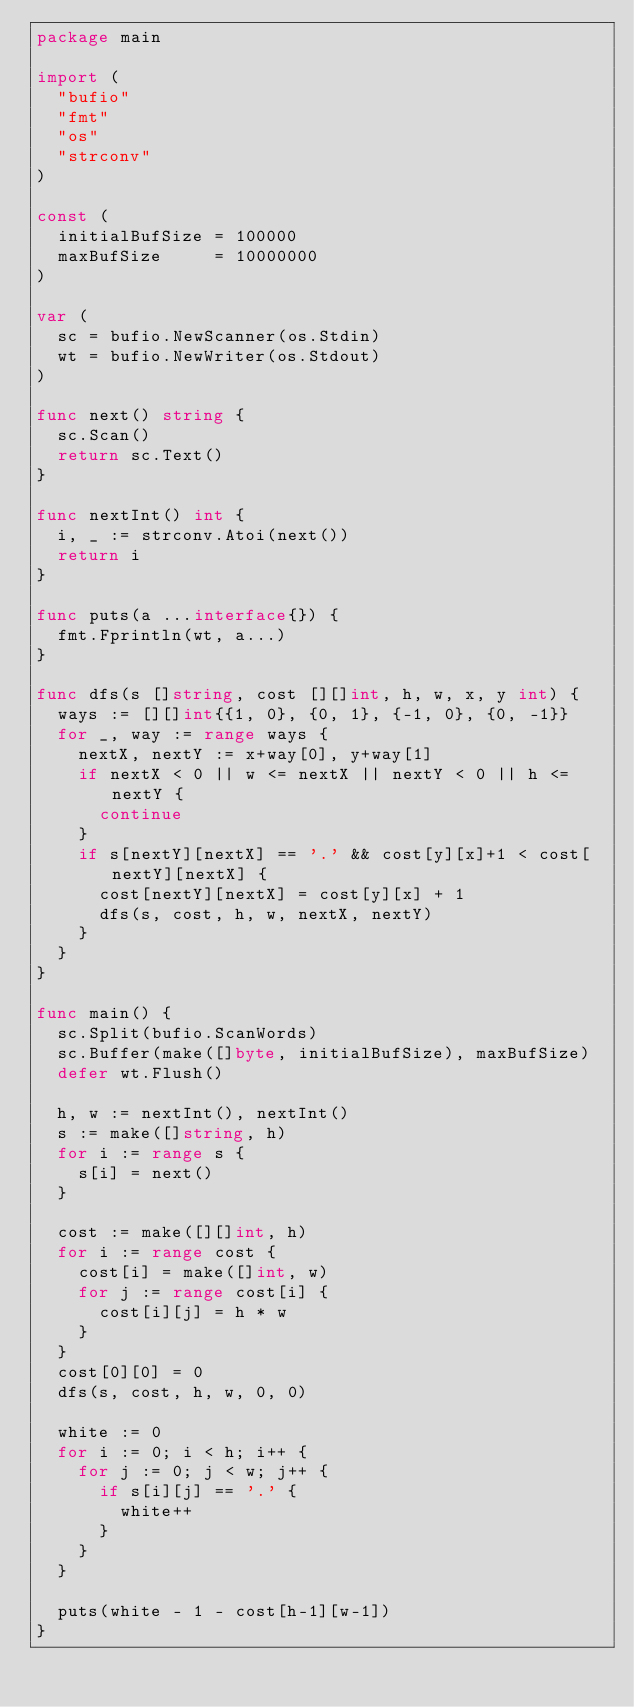<code> <loc_0><loc_0><loc_500><loc_500><_Go_>package main

import (
	"bufio"
	"fmt"
	"os"
	"strconv"
)

const (
	initialBufSize = 100000
	maxBufSize     = 10000000
)

var (
	sc = bufio.NewScanner(os.Stdin)
	wt = bufio.NewWriter(os.Stdout)
)

func next() string {
	sc.Scan()
	return sc.Text()
}

func nextInt() int {
	i, _ := strconv.Atoi(next())
	return i
}

func puts(a ...interface{}) {
	fmt.Fprintln(wt, a...)
}

func dfs(s []string, cost [][]int, h, w, x, y int) {
	ways := [][]int{{1, 0}, {0, 1}, {-1, 0}, {0, -1}}
	for _, way := range ways {
		nextX, nextY := x+way[0], y+way[1]
		if nextX < 0 || w <= nextX || nextY < 0 || h <= nextY {
			continue
		}
		if s[nextY][nextX] == '.' && cost[y][x]+1 < cost[nextY][nextX] {
			cost[nextY][nextX] = cost[y][x] + 1
			dfs(s, cost, h, w, nextX, nextY)
		}
	}
}

func main() {
	sc.Split(bufio.ScanWords)
	sc.Buffer(make([]byte, initialBufSize), maxBufSize)
	defer wt.Flush()

	h, w := nextInt(), nextInt()
	s := make([]string, h)
	for i := range s {
		s[i] = next()
	}

	cost := make([][]int, h)
	for i := range cost {
		cost[i] = make([]int, w)
		for j := range cost[i] {
			cost[i][j] = h * w
		}
	}
	cost[0][0] = 0
	dfs(s, cost, h, w, 0, 0)

	white := 0
	for i := 0; i < h; i++ {
		for j := 0; j < w; j++ {
			if s[i][j] == '.' {
				white++
			}
		}
	}

	puts(white - 1 - cost[h-1][w-1])
}
</code> 